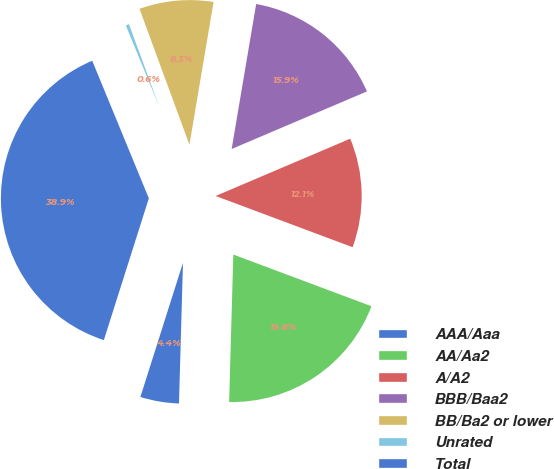Convert chart. <chart><loc_0><loc_0><loc_500><loc_500><pie_chart><fcel>AAA/Aaa<fcel>AA/Aa2<fcel>A/A2<fcel>BBB/Baa2<fcel>BB/Ba2 or lower<fcel>Unrated<fcel>Total<nl><fcel>4.44%<fcel>19.75%<fcel>12.1%<fcel>15.93%<fcel>8.27%<fcel>0.61%<fcel>38.89%<nl></chart> 